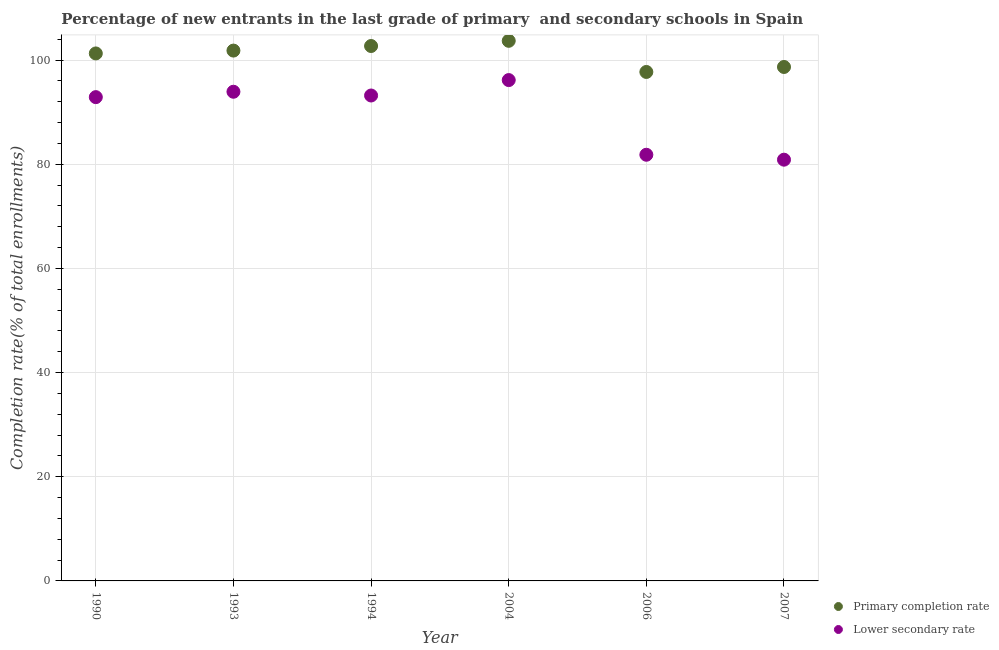Is the number of dotlines equal to the number of legend labels?
Make the answer very short. Yes. What is the completion rate in secondary schools in 1990?
Provide a short and direct response. 92.9. Across all years, what is the maximum completion rate in secondary schools?
Keep it short and to the point. 96.17. Across all years, what is the minimum completion rate in secondary schools?
Offer a very short reply. 80.89. In which year was the completion rate in secondary schools maximum?
Offer a very short reply. 2004. In which year was the completion rate in primary schools minimum?
Offer a terse response. 2006. What is the total completion rate in secondary schools in the graph?
Give a very brief answer. 538.94. What is the difference between the completion rate in secondary schools in 2004 and that in 2007?
Make the answer very short. 15.29. What is the difference between the completion rate in primary schools in 2007 and the completion rate in secondary schools in 2004?
Keep it short and to the point. 2.51. What is the average completion rate in secondary schools per year?
Keep it short and to the point. 89.82. In the year 1990, what is the difference between the completion rate in primary schools and completion rate in secondary schools?
Your response must be concise. 8.39. What is the ratio of the completion rate in secondary schools in 1994 to that in 2004?
Provide a short and direct response. 0.97. Is the difference between the completion rate in secondary schools in 2004 and 2007 greater than the difference between the completion rate in primary schools in 2004 and 2007?
Your response must be concise. Yes. What is the difference between the highest and the second highest completion rate in secondary schools?
Give a very brief answer. 2.24. What is the difference between the highest and the lowest completion rate in primary schools?
Ensure brevity in your answer.  5.98. Is the sum of the completion rate in secondary schools in 1990 and 2007 greater than the maximum completion rate in primary schools across all years?
Your response must be concise. Yes. Does the completion rate in secondary schools monotonically increase over the years?
Make the answer very short. No. Is the completion rate in primary schools strictly less than the completion rate in secondary schools over the years?
Your response must be concise. No. How many dotlines are there?
Your answer should be very brief. 2. How many years are there in the graph?
Give a very brief answer. 6. What is the difference between two consecutive major ticks on the Y-axis?
Your answer should be very brief. 20. Does the graph contain any zero values?
Your response must be concise. No. Does the graph contain grids?
Make the answer very short. Yes. How are the legend labels stacked?
Your response must be concise. Vertical. What is the title of the graph?
Make the answer very short. Percentage of new entrants in the last grade of primary  and secondary schools in Spain. What is the label or title of the X-axis?
Provide a short and direct response. Year. What is the label or title of the Y-axis?
Provide a short and direct response. Completion rate(% of total enrollments). What is the Completion rate(% of total enrollments) in Primary completion rate in 1990?
Your response must be concise. 101.29. What is the Completion rate(% of total enrollments) of Lower secondary rate in 1990?
Offer a terse response. 92.9. What is the Completion rate(% of total enrollments) of Primary completion rate in 1993?
Keep it short and to the point. 101.84. What is the Completion rate(% of total enrollments) in Lower secondary rate in 1993?
Offer a terse response. 93.93. What is the Completion rate(% of total enrollments) in Primary completion rate in 1994?
Provide a short and direct response. 102.72. What is the Completion rate(% of total enrollments) of Lower secondary rate in 1994?
Your answer should be very brief. 93.21. What is the Completion rate(% of total enrollments) of Primary completion rate in 2004?
Give a very brief answer. 103.71. What is the Completion rate(% of total enrollments) of Lower secondary rate in 2004?
Your response must be concise. 96.17. What is the Completion rate(% of total enrollments) of Primary completion rate in 2006?
Your answer should be very brief. 97.73. What is the Completion rate(% of total enrollments) in Lower secondary rate in 2006?
Make the answer very short. 81.83. What is the Completion rate(% of total enrollments) of Primary completion rate in 2007?
Offer a terse response. 98.69. What is the Completion rate(% of total enrollments) of Lower secondary rate in 2007?
Offer a terse response. 80.89. Across all years, what is the maximum Completion rate(% of total enrollments) in Primary completion rate?
Provide a succinct answer. 103.71. Across all years, what is the maximum Completion rate(% of total enrollments) in Lower secondary rate?
Your answer should be very brief. 96.17. Across all years, what is the minimum Completion rate(% of total enrollments) of Primary completion rate?
Provide a succinct answer. 97.73. Across all years, what is the minimum Completion rate(% of total enrollments) in Lower secondary rate?
Provide a succinct answer. 80.89. What is the total Completion rate(% of total enrollments) of Primary completion rate in the graph?
Provide a short and direct response. 605.98. What is the total Completion rate(% of total enrollments) of Lower secondary rate in the graph?
Your response must be concise. 538.94. What is the difference between the Completion rate(% of total enrollments) in Primary completion rate in 1990 and that in 1993?
Ensure brevity in your answer.  -0.55. What is the difference between the Completion rate(% of total enrollments) of Lower secondary rate in 1990 and that in 1993?
Ensure brevity in your answer.  -1.03. What is the difference between the Completion rate(% of total enrollments) in Primary completion rate in 1990 and that in 1994?
Your response must be concise. -1.42. What is the difference between the Completion rate(% of total enrollments) in Lower secondary rate in 1990 and that in 1994?
Your answer should be compact. -0.31. What is the difference between the Completion rate(% of total enrollments) of Primary completion rate in 1990 and that in 2004?
Provide a short and direct response. -2.42. What is the difference between the Completion rate(% of total enrollments) of Lower secondary rate in 1990 and that in 2004?
Offer a terse response. -3.28. What is the difference between the Completion rate(% of total enrollments) in Primary completion rate in 1990 and that in 2006?
Offer a very short reply. 3.56. What is the difference between the Completion rate(% of total enrollments) in Lower secondary rate in 1990 and that in 2006?
Keep it short and to the point. 11.06. What is the difference between the Completion rate(% of total enrollments) in Primary completion rate in 1990 and that in 2007?
Your answer should be compact. 2.6. What is the difference between the Completion rate(% of total enrollments) of Lower secondary rate in 1990 and that in 2007?
Provide a succinct answer. 12.01. What is the difference between the Completion rate(% of total enrollments) in Primary completion rate in 1993 and that in 1994?
Offer a very short reply. -0.88. What is the difference between the Completion rate(% of total enrollments) of Lower secondary rate in 1993 and that in 1994?
Provide a succinct answer. 0.72. What is the difference between the Completion rate(% of total enrollments) of Primary completion rate in 1993 and that in 2004?
Your answer should be compact. -1.88. What is the difference between the Completion rate(% of total enrollments) of Lower secondary rate in 1993 and that in 2004?
Provide a succinct answer. -2.24. What is the difference between the Completion rate(% of total enrollments) in Primary completion rate in 1993 and that in 2006?
Provide a short and direct response. 4.1. What is the difference between the Completion rate(% of total enrollments) in Lower secondary rate in 1993 and that in 2006?
Offer a very short reply. 12.1. What is the difference between the Completion rate(% of total enrollments) in Primary completion rate in 1993 and that in 2007?
Offer a terse response. 3.15. What is the difference between the Completion rate(% of total enrollments) in Lower secondary rate in 1993 and that in 2007?
Your answer should be very brief. 13.04. What is the difference between the Completion rate(% of total enrollments) of Primary completion rate in 1994 and that in 2004?
Provide a succinct answer. -1. What is the difference between the Completion rate(% of total enrollments) of Lower secondary rate in 1994 and that in 2004?
Offer a very short reply. -2.96. What is the difference between the Completion rate(% of total enrollments) of Primary completion rate in 1994 and that in 2006?
Offer a very short reply. 4.98. What is the difference between the Completion rate(% of total enrollments) in Lower secondary rate in 1994 and that in 2006?
Provide a short and direct response. 11.38. What is the difference between the Completion rate(% of total enrollments) in Primary completion rate in 1994 and that in 2007?
Offer a terse response. 4.03. What is the difference between the Completion rate(% of total enrollments) of Lower secondary rate in 1994 and that in 2007?
Offer a very short reply. 12.32. What is the difference between the Completion rate(% of total enrollments) of Primary completion rate in 2004 and that in 2006?
Provide a succinct answer. 5.98. What is the difference between the Completion rate(% of total enrollments) in Lower secondary rate in 2004 and that in 2006?
Ensure brevity in your answer.  14.34. What is the difference between the Completion rate(% of total enrollments) of Primary completion rate in 2004 and that in 2007?
Provide a succinct answer. 5.02. What is the difference between the Completion rate(% of total enrollments) in Lower secondary rate in 2004 and that in 2007?
Your response must be concise. 15.29. What is the difference between the Completion rate(% of total enrollments) of Primary completion rate in 2006 and that in 2007?
Provide a short and direct response. -0.96. What is the difference between the Completion rate(% of total enrollments) in Lower secondary rate in 2006 and that in 2007?
Give a very brief answer. 0.95. What is the difference between the Completion rate(% of total enrollments) of Primary completion rate in 1990 and the Completion rate(% of total enrollments) of Lower secondary rate in 1993?
Offer a terse response. 7.36. What is the difference between the Completion rate(% of total enrollments) of Primary completion rate in 1990 and the Completion rate(% of total enrollments) of Lower secondary rate in 1994?
Your answer should be compact. 8.08. What is the difference between the Completion rate(% of total enrollments) in Primary completion rate in 1990 and the Completion rate(% of total enrollments) in Lower secondary rate in 2004?
Keep it short and to the point. 5.12. What is the difference between the Completion rate(% of total enrollments) of Primary completion rate in 1990 and the Completion rate(% of total enrollments) of Lower secondary rate in 2006?
Your answer should be very brief. 19.46. What is the difference between the Completion rate(% of total enrollments) of Primary completion rate in 1990 and the Completion rate(% of total enrollments) of Lower secondary rate in 2007?
Your answer should be compact. 20.4. What is the difference between the Completion rate(% of total enrollments) in Primary completion rate in 1993 and the Completion rate(% of total enrollments) in Lower secondary rate in 1994?
Your answer should be compact. 8.63. What is the difference between the Completion rate(% of total enrollments) in Primary completion rate in 1993 and the Completion rate(% of total enrollments) in Lower secondary rate in 2004?
Your answer should be very brief. 5.66. What is the difference between the Completion rate(% of total enrollments) of Primary completion rate in 1993 and the Completion rate(% of total enrollments) of Lower secondary rate in 2006?
Keep it short and to the point. 20. What is the difference between the Completion rate(% of total enrollments) of Primary completion rate in 1993 and the Completion rate(% of total enrollments) of Lower secondary rate in 2007?
Give a very brief answer. 20.95. What is the difference between the Completion rate(% of total enrollments) of Primary completion rate in 1994 and the Completion rate(% of total enrollments) of Lower secondary rate in 2004?
Provide a succinct answer. 6.54. What is the difference between the Completion rate(% of total enrollments) of Primary completion rate in 1994 and the Completion rate(% of total enrollments) of Lower secondary rate in 2006?
Offer a very short reply. 20.88. What is the difference between the Completion rate(% of total enrollments) of Primary completion rate in 1994 and the Completion rate(% of total enrollments) of Lower secondary rate in 2007?
Your response must be concise. 21.83. What is the difference between the Completion rate(% of total enrollments) in Primary completion rate in 2004 and the Completion rate(% of total enrollments) in Lower secondary rate in 2006?
Keep it short and to the point. 21.88. What is the difference between the Completion rate(% of total enrollments) in Primary completion rate in 2004 and the Completion rate(% of total enrollments) in Lower secondary rate in 2007?
Your response must be concise. 22.82. What is the difference between the Completion rate(% of total enrollments) of Primary completion rate in 2006 and the Completion rate(% of total enrollments) of Lower secondary rate in 2007?
Your answer should be compact. 16.84. What is the average Completion rate(% of total enrollments) in Primary completion rate per year?
Provide a short and direct response. 101. What is the average Completion rate(% of total enrollments) in Lower secondary rate per year?
Provide a short and direct response. 89.82. In the year 1990, what is the difference between the Completion rate(% of total enrollments) in Primary completion rate and Completion rate(% of total enrollments) in Lower secondary rate?
Offer a terse response. 8.39. In the year 1993, what is the difference between the Completion rate(% of total enrollments) of Primary completion rate and Completion rate(% of total enrollments) of Lower secondary rate?
Make the answer very short. 7.9. In the year 1994, what is the difference between the Completion rate(% of total enrollments) in Primary completion rate and Completion rate(% of total enrollments) in Lower secondary rate?
Keep it short and to the point. 9.5. In the year 2004, what is the difference between the Completion rate(% of total enrollments) in Primary completion rate and Completion rate(% of total enrollments) in Lower secondary rate?
Your response must be concise. 7.54. In the year 2006, what is the difference between the Completion rate(% of total enrollments) in Primary completion rate and Completion rate(% of total enrollments) in Lower secondary rate?
Offer a terse response. 15.9. In the year 2007, what is the difference between the Completion rate(% of total enrollments) in Primary completion rate and Completion rate(% of total enrollments) in Lower secondary rate?
Ensure brevity in your answer.  17.8. What is the ratio of the Completion rate(% of total enrollments) of Primary completion rate in 1990 to that in 1994?
Your answer should be compact. 0.99. What is the ratio of the Completion rate(% of total enrollments) in Lower secondary rate in 1990 to that in 1994?
Provide a succinct answer. 1. What is the ratio of the Completion rate(% of total enrollments) in Primary completion rate in 1990 to that in 2004?
Offer a very short reply. 0.98. What is the ratio of the Completion rate(% of total enrollments) of Lower secondary rate in 1990 to that in 2004?
Ensure brevity in your answer.  0.97. What is the ratio of the Completion rate(% of total enrollments) in Primary completion rate in 1990 to that in 2006?
Offer a terse response. 1.04. What is the ratio of the Completion rate(% of total enrollments) in Lower secondary rate in 1990 to that in 2006?
Your answer should be compact. 1.14. What is the ratio of the Completion rate(% of total enrollments) in Primary completion rate in 1990 to that in 2007?
Give a very brief answer. 1.03. What is the ratio of the Completion rate(% of total enrollments) in Lower secondary rate in 1990 to that in 2007?
Ensure brevity in your answer.  1.15. What is the ratio of the Completion rate(% of total enrollments) of Primary completion rate in 1993 to that in 1994?
Provide a succinct answer. 0.99. What is the ratio of the Completion rate(% of total enrollments) of Lower secondary rate in 1993 to that in 1994?
Provide a succinct answer. 1.01. What is the ratio of the Completion rate(% of total enrollments) in Primary completion rate in 1993 to that in 2004?
Offer a terse response. 0.98. What is the ratio of the Completion rate(% of total enrollments) in Lower secondary rate in 1993 to that in 2004?
Provide a short and direct response. 0.98. What is the ratio of the Completion rate(% of total enrollments) of Primary completion rate in 1993 to that in 2006?
Provide a short and direct response. 1.04. What is the ratio of the Completion rate(% of total enrollments) in Lower secondary rate in 1993 to that in 2006?
Offer a very short reply. 1.15. What is the ratio of the Completion rate(% of total enrollments) in Primary completion rate in 1993 to that in 2007?
Give a very brief answer. 1.03. What is the ratio of the Completion rate(% of total enrollments) of Lower secondary rate in 1993 to that in 2007?
Your answer should be compact. 1.16. What is the ratio of the Completion rate(% of total enrollments) of Primary completion rate in 1994 to that in 2004?
Your answer should be very brief. 0.99. What is the ratio of the Completion rate(% of total enrollments) in Lower secondary rate in 1994 to that in 2004?
Your answer should be very brief. 0.97. What is the ratio of the Completion rate(% of total enrollments) in Primary completion rate in 1994 to that in 2006?
Keep it short and to the point. 1.05. What is the ratio of the Completion rate(% of total enrollments) of Lower secondary rate in 1994 to that in 2006?
Your answer should be compact. 1.14. What is the ratio of the Completion rate(% of total enrollments) in Primary completion rate in 1994 to that in 2007?
Keep it short and to the point. 1.04. What is the ratio of the Completion rate(% of total enrollments) in Lower secondary rate in 1994 to that in 2007?
Give a very brief answer. 1.15. What is the ratio of the Completion rate(% of total enrollments) in Primary completion rate in 2004 to that in 2006?
Your response must be concise. 1.06. What is the ratio of the Completion rate(% of total enrollments) in Lower secondary rate in 2004 to that in 2006?
Provide a short and direct response. 1.18. What is the ratio of the Completion rate(% of total enrollments) of Primary completion rate in 2004 to that in 2007?
Give a very brief answer. 1.05. What is the ratio of the Completion rate(% of total enrollments) of Lower secondary rate in 2004 to that in 2007?
Offer a very short reply. 1.19. What is the ratio of the Completion rate(% of total enrollments) in Primary completion rate in 2006 to that in 2007?
Your answer should be very brief. 0.99. What is the ratio of the Completion rate(% of total enrollments) in Lower secondary rate in 2006 to that in 2007?
Your answer should be very brief. 1.01. What is the difference between the highest and the second highest Completion rate(% of total enrollments) of Primary completion rate?
Offer a terse response. 1. What is the difference between the highest and the second highest Completion rate(% of total enrollments) in Lower secondary rate?
Keep it short and to the point. 2.24. What is the difference between the highest and the lowest Completion rate(% of total enrollments) of Primary completion rate?
Your answer should be very brief. 5.98. What is the difference between the highest and the lowest Completion rate(% of total enrollments) of Lower secondary rate?
Your answer should be very brief. 15.29. 